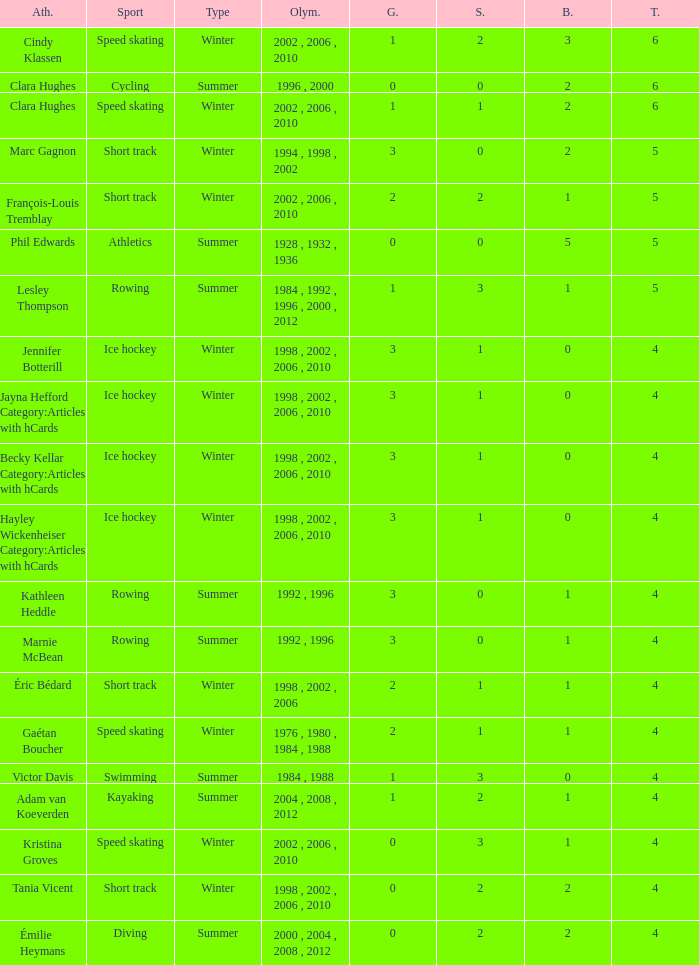What is the highest total medals winter athlete Clara Hughes has? 6.0. 